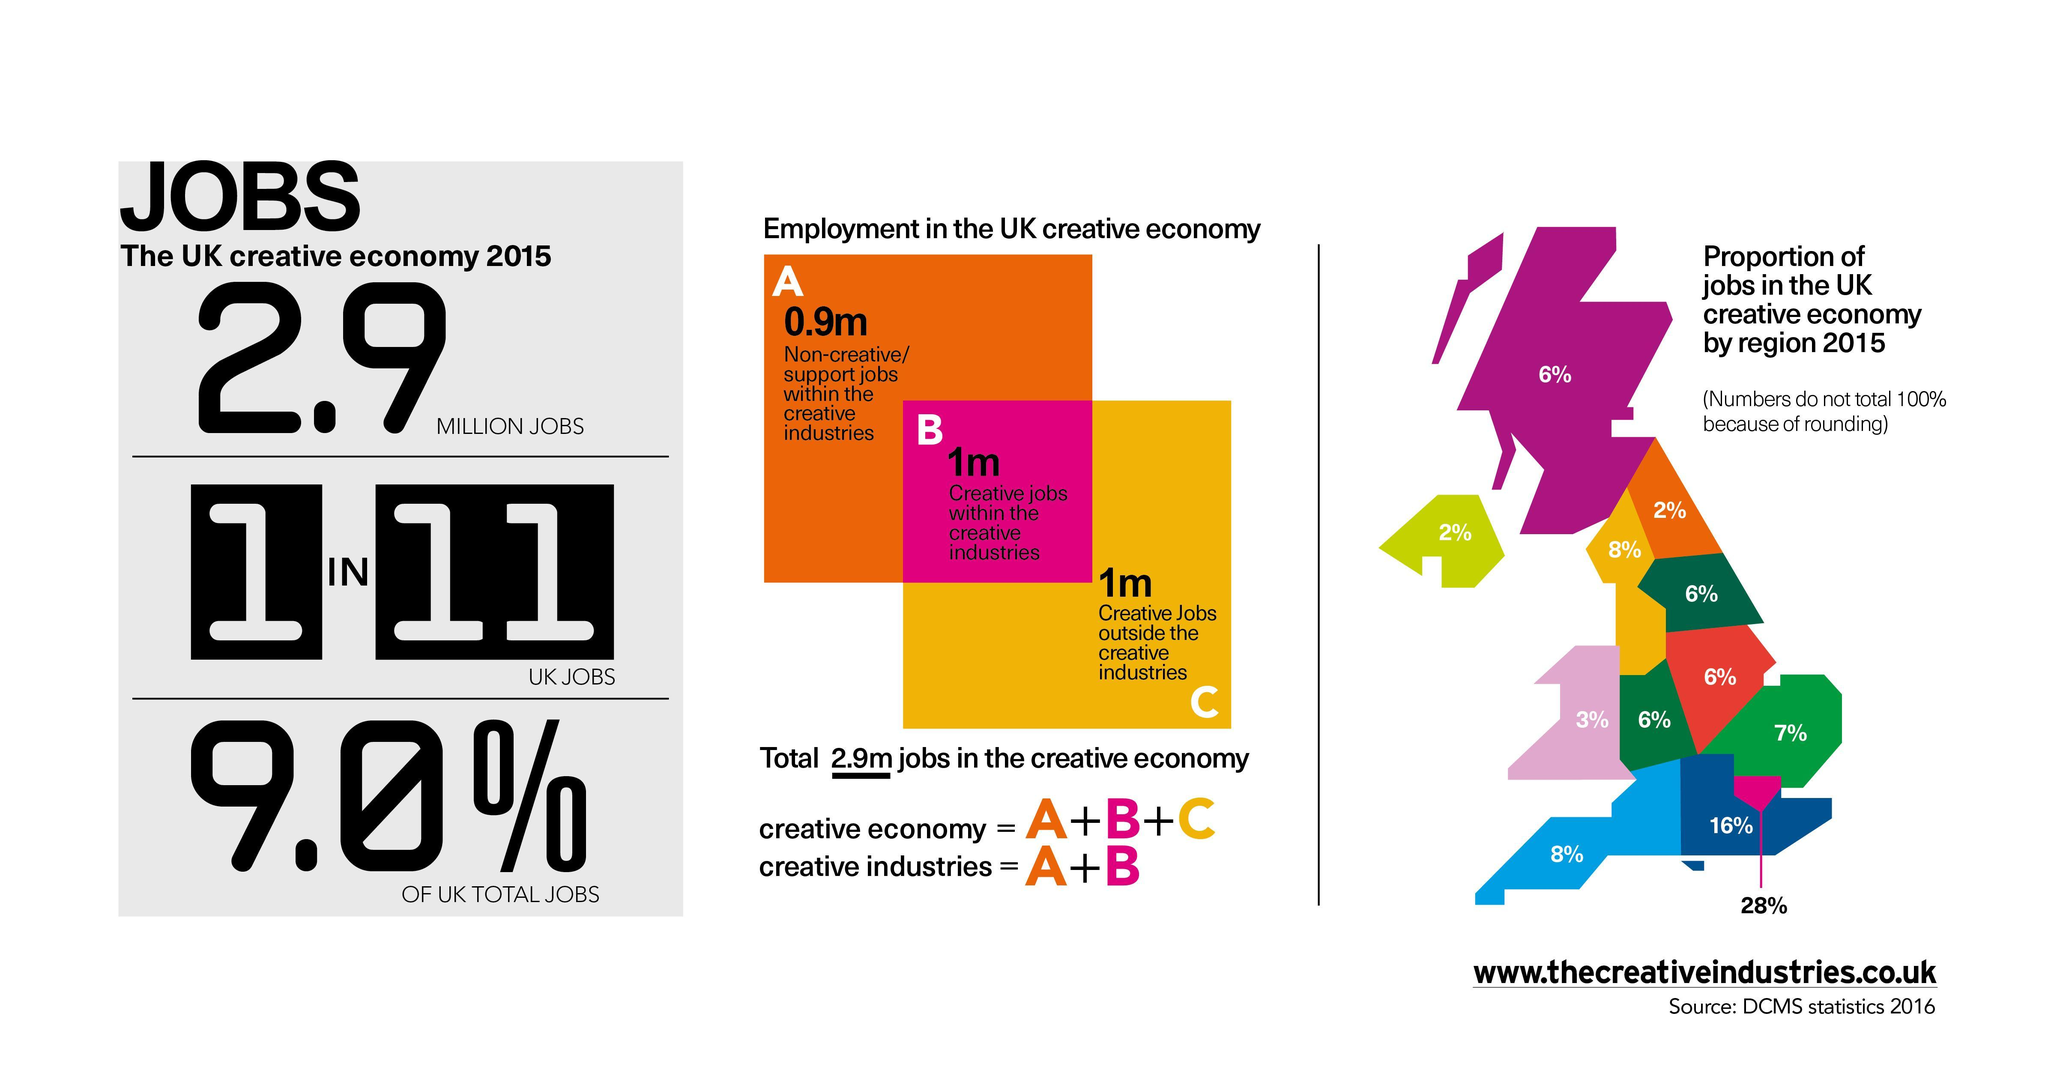What is the total jobs in the creative industry in millions?
Answer the question with a short phrase. 1.9 What is the percentage of non-creative jobs within creative industry in the UK creative economy? 31% What does the letter A represents in the middle graphics? non-creative/support jobs within creative industries What does the color pink represents in the middle graphics? creative jobs within the creative industries What does the letter B represents in the middle graphics? creative jobs within the creative industries What is the percentage of creative jobs outside creative industry in the UK creative economy? 34% What does the color orange represents in the middle graphics? non-creative/support jobs within creative industries What is the percentage of jobs in creative economy UK? 9.0 What does the color yellow represents in the middle graphics? creative jobs outside the creative industries What does the letter C represents in the middle graphics? creative jobs outside the creative industries What is the percentage of creative jobs within the creative industry in the UK creative economy? 34% What is the total jobs in the non-creative industry in millions? 2 